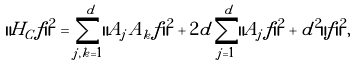Convert formula to latex. <formula><loc_0><loc_0><loc_500><loc_500>\| H _ { C } f \| ^ { 2 } = \sum _ { j , k = 1 } ^ { d } \| A _ { j } A _ { k } f \| ^ { 2 } + 2 d \sum _ { j = 1 } ^ { d } \| A _ { j } f \| ^ { 2 } + d ^ { 2 } \| f \| ^ { 2 } ,</formula> 